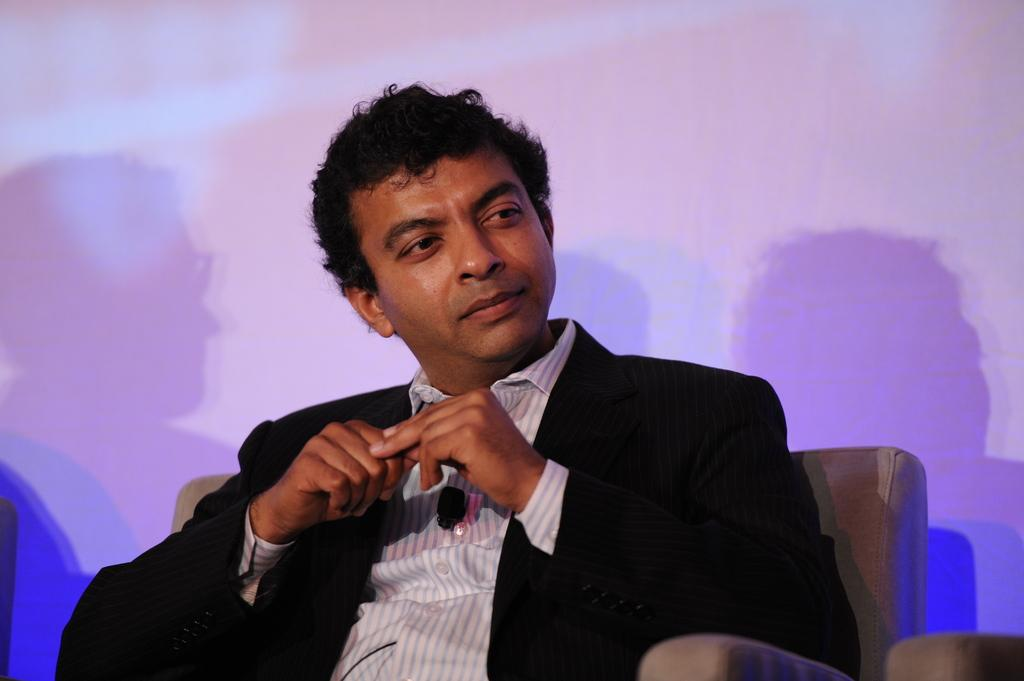Who is present in the image? There is a man in the image. What is the man doing in the image? The man is sitting on a sofa chair. What can be seen behind the man? There is a wall behind the man. What is unique about the wall in the image? There are shadows of people on the wall. What type of steam is coming from the man's seat in the image? There is no steam present in the image, and the man is sitting on a sofa chair, not a seat that produces steam. 